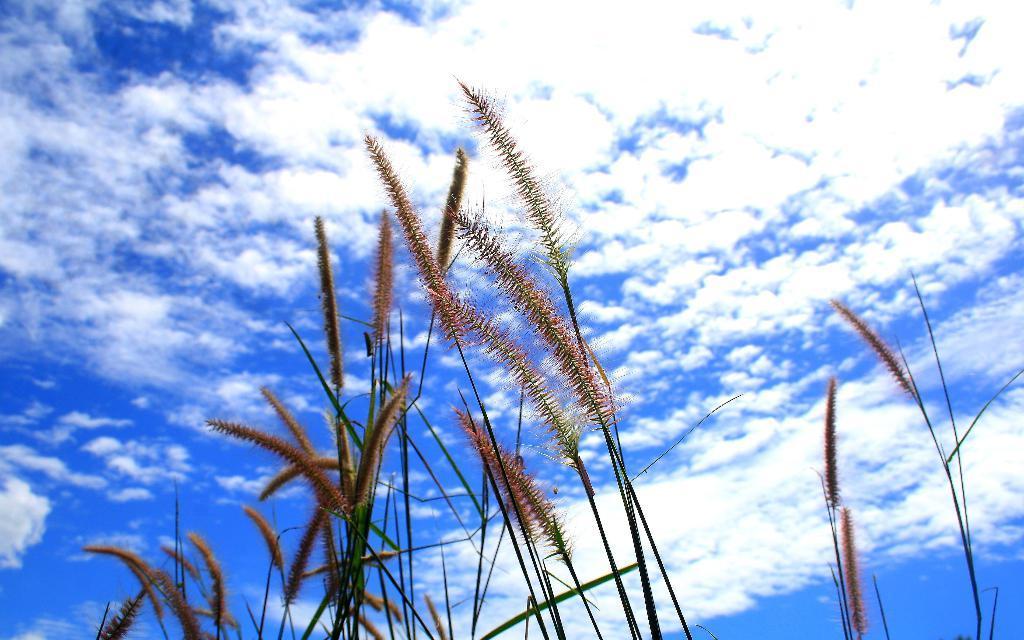Please provide a concise description of this image. In this picture I can see the grass. In the background I can see the sky and clouds. 